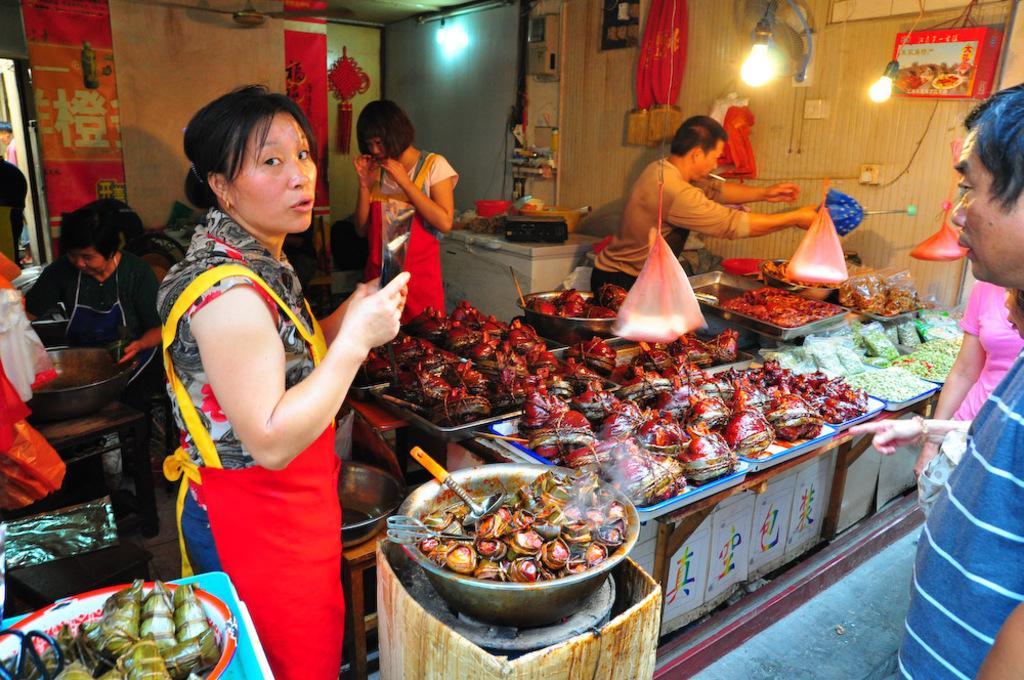Describe this image in one or two sentences. In this image there are people, tables with objects on it in the left corner. There are people on the right corner. There is floor at the bottom. There are people, tables with food items on it in the foreground. There is a wall in the background. And there is a roof at the top. 